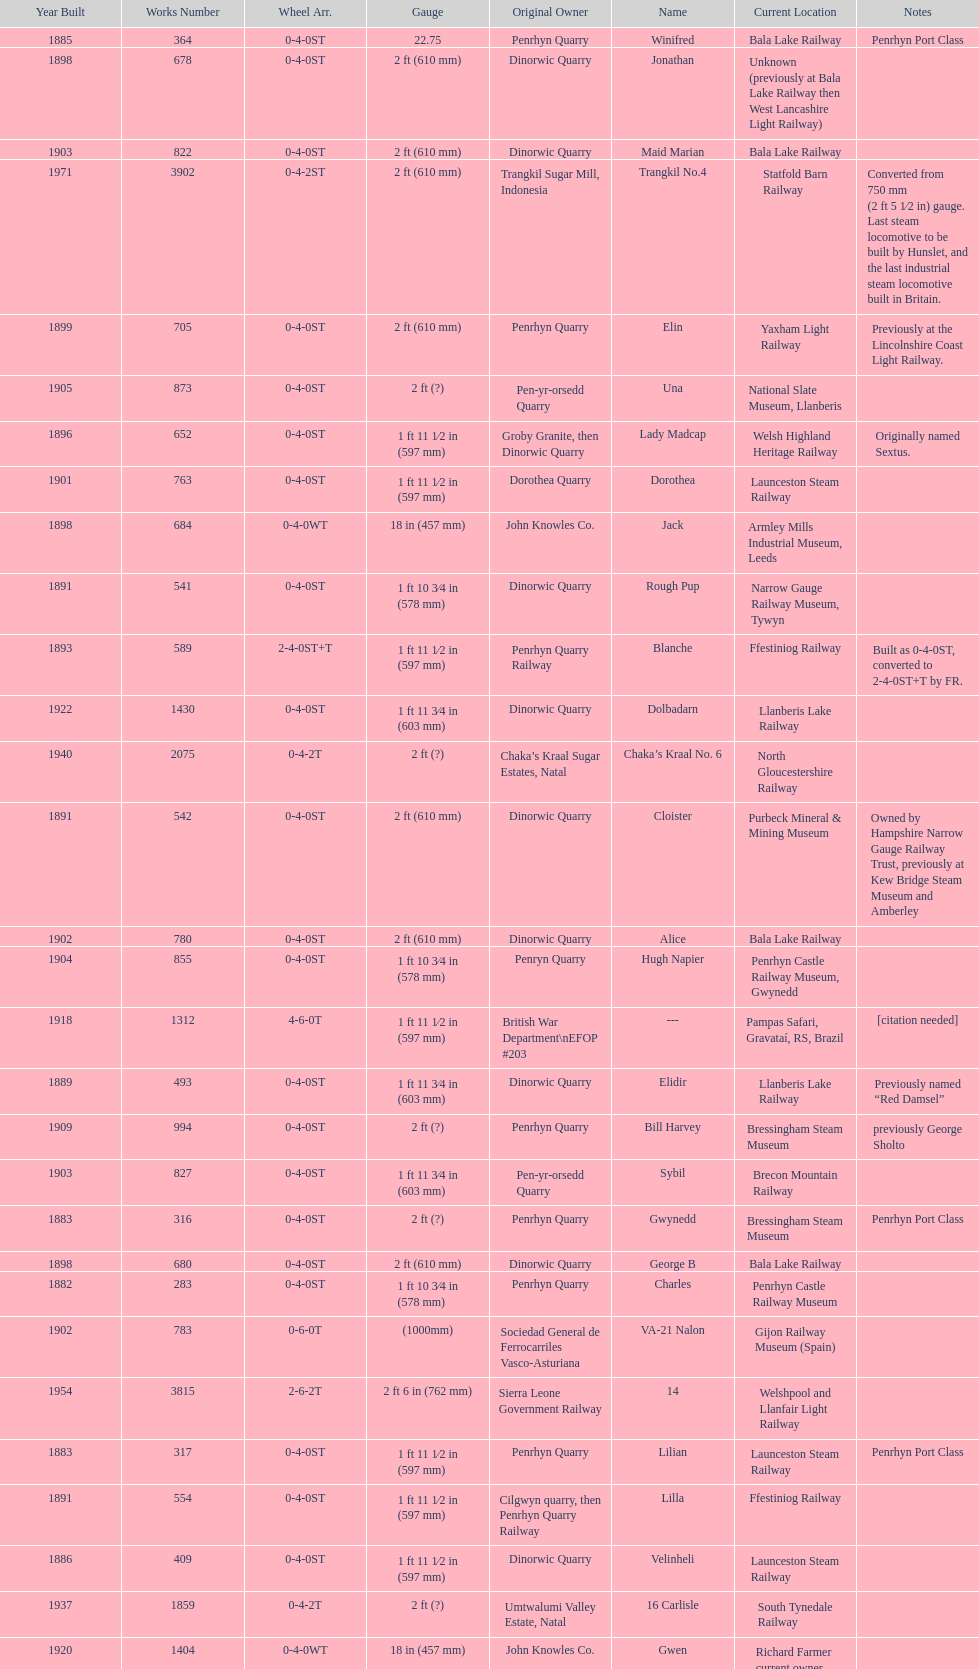Which original owner had the most locomotives? Penrhyn Quarry. 